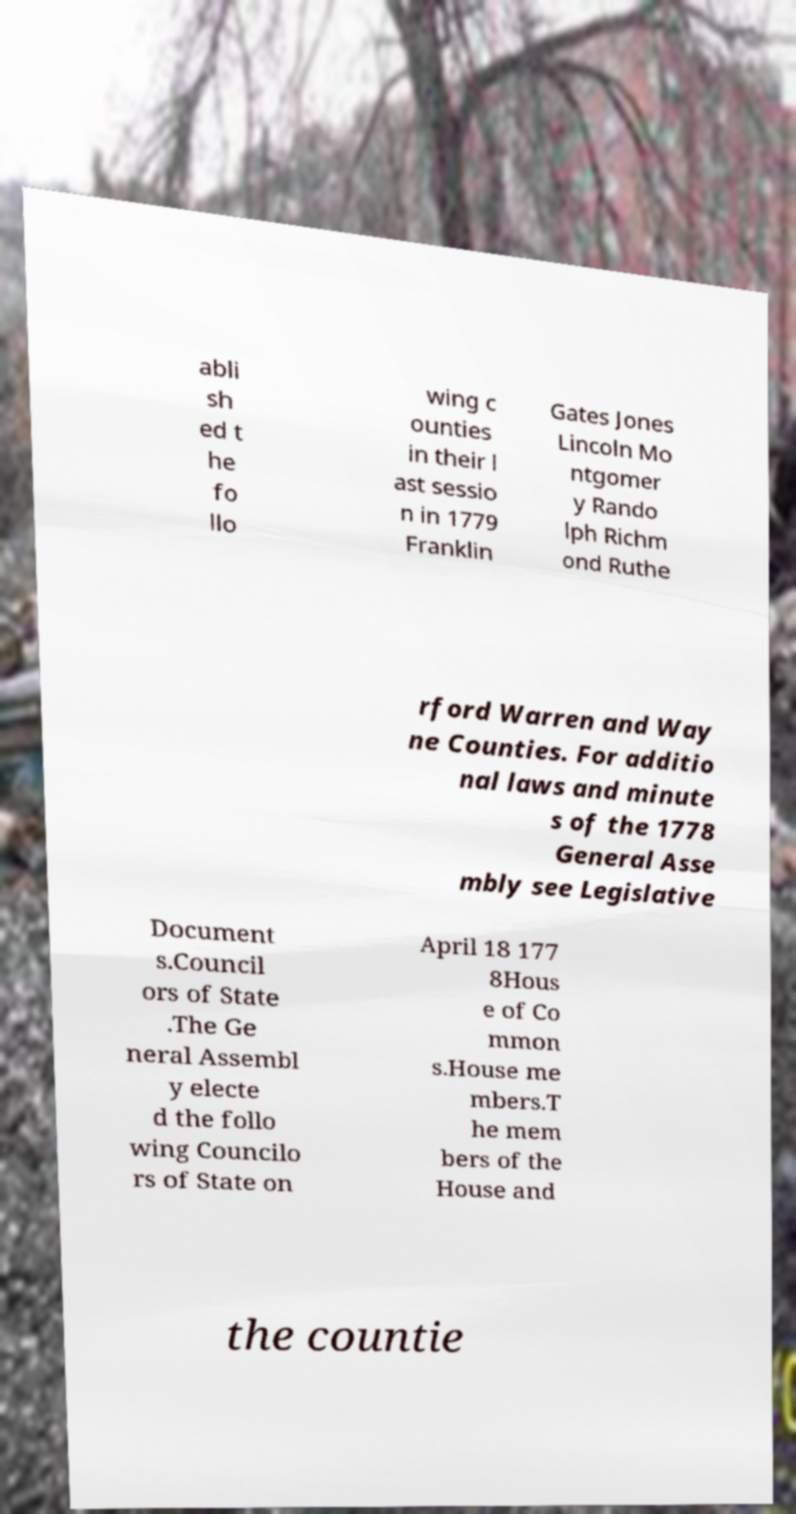Can you read and provide the text displayed in the image?This photo seems to have some interesting text. Can you extract and type it out for me? abli sh ed t he fo llo wing c ounties in their l ast sessio n in 1779 Franklin Gates Jones Lincoln Mo ntgomer y Rando lph Richm ond Ruthe rford Warren and Way ne Counties. For additio nal laws and minute s of the 1778 General Asse mbly see Legislative Document s.Council ors of State .The Ge neral Assembl y electe d the follo wing Councilo rs of State on April 18 177 8Hous e of Co mmon s.House me mbers.T he mem bers of the House and the countie 